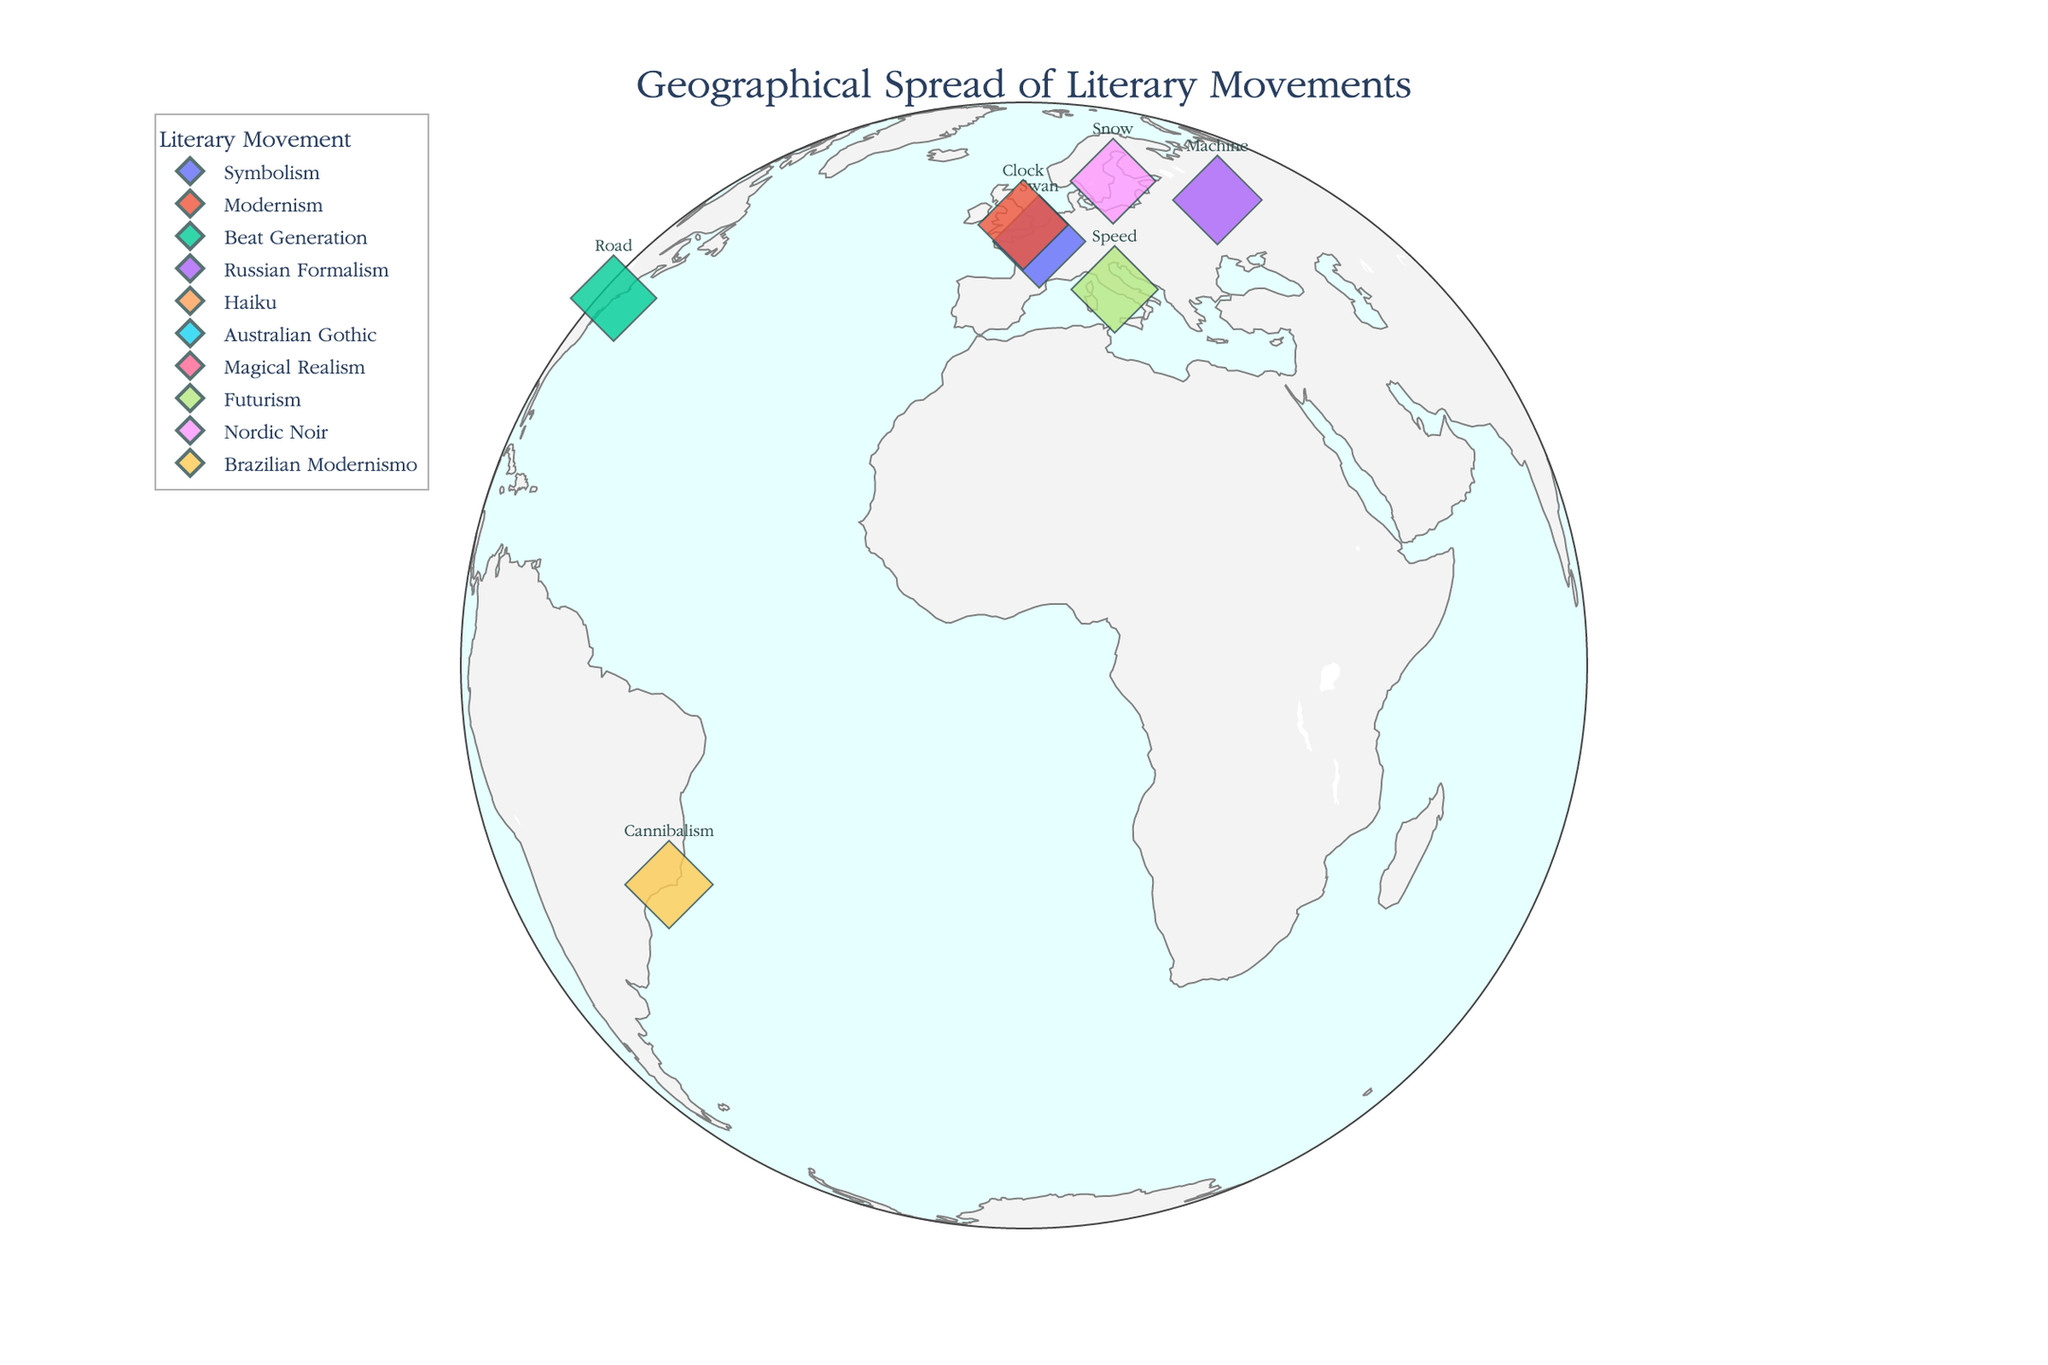What's the title of the figure? Look at the top of the figure where the title is typically located. The title of the figure is displayed prominently to indicate the content.
Answer: Geographical Spread of Literary Movements Which city is associated with the Haiku movement? Identify the data points on the map and look up the description that matches "Haiku". The corresponding city is Tokyo, Japan, marked by its coordinates.
Answer: Tokyo What is the key symbol for the Beat Generation? Find the data point labeled as Beat Generation and check its attributes for the key symbol.
Answer: Road Which literary movement has the highest influence score? Compare the influence scores of all movements in the data. The highest score belongs to the movement with the Key_Symbol "Mirror".
Answer: Magical Realism How many literary movements are represented in South America? Locate South America on the map and count the unique literary movements marked by data points.
Answer: 1 Which author represents Russian Formalism? Look at the data point associated with Russian Formalism and check the author attribute.
Answer: Viktor Shklovsky What is the average influence score of the movements located in Europe? Identify the movements in Europe (Paris, London, Moscow, Rome, Stockholm), sum their influence scores (9.2 + 8.7 + 8.5 + 8.1 + 7.8), then divide by the number of these movements.
Answer: 8.46 Which movement is geographically closest to the modernism movement? Identify the latitude and longitude of Modernism (London) and find the geographically nearest point by comparing distances between coordinates.
Answer: Symbolism (Paris) How does the key symbol for Australian Gothic contrast with that for Haiku? Compare the key symbols associated with Australian Gothic (Desert) and Haiku (Cherry Blossom), noting the thematic and cultural differences.
Answer: Desert vs. Cherry Blossom 